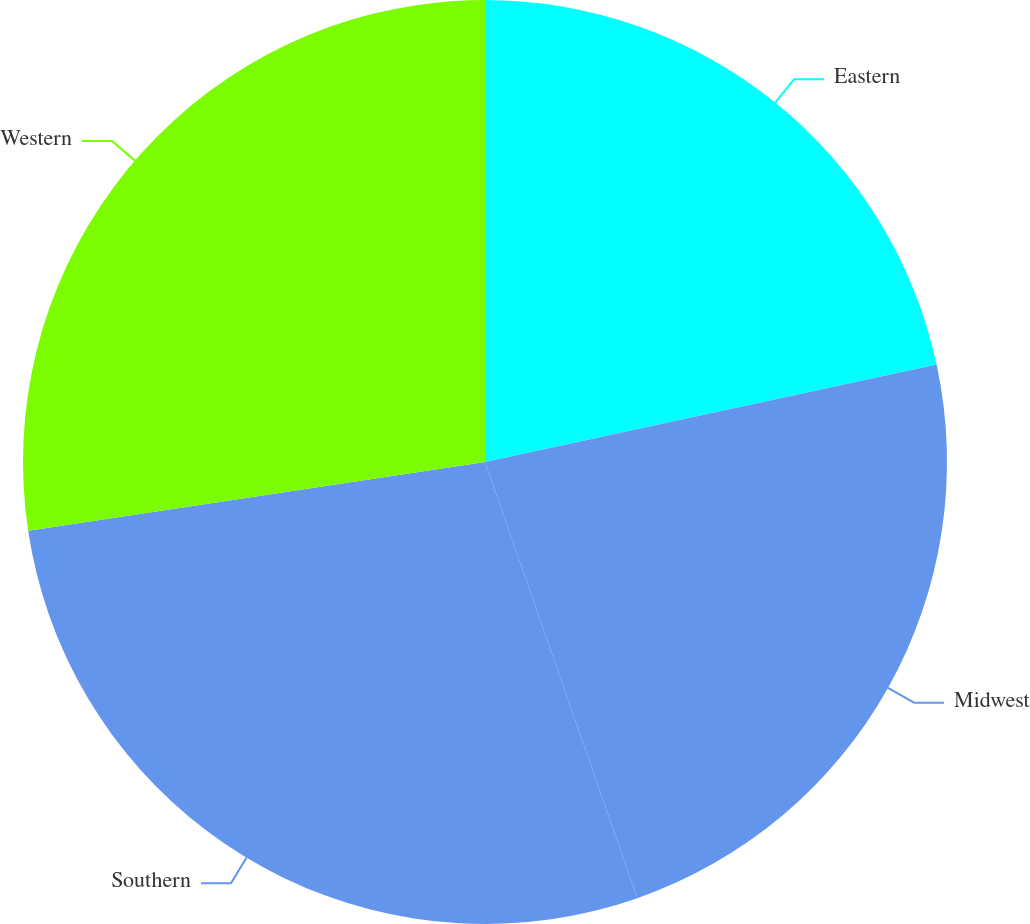Convert chart. <chart><loc_0><loc_0><loc_500><loc_500><pie_chart><fcel>Eastern<fcel>Midwest<fcel>Southern<fcel>Western<nl><fcel>21.62%<fcel>23.03%<fcel>27.97%<fcel>27.38%<nl></chart> 